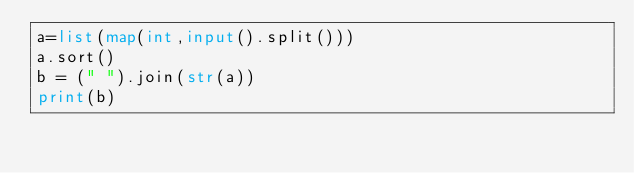<code> <loc_0><loc_0><loc_500><loc_500><_Python_>a=list(map(int,input().split()))
a.sort()
b = (" ").join(str(a))
print(b)</code> 